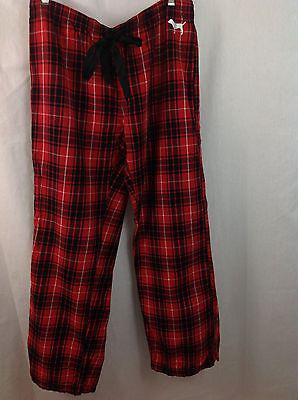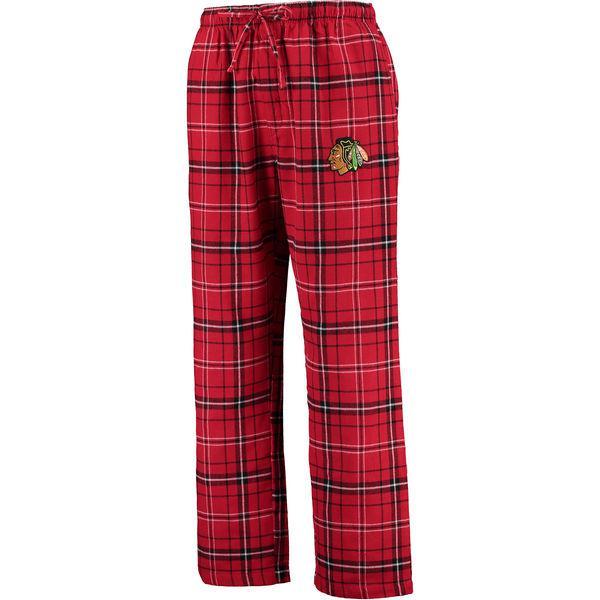The first image is the image on the left, the second image is the image on the right. Examine the images to the left and right. Is the description "one pair of pants is worn by a human and the other is by itself." accurate? Answer yes or no. No. 